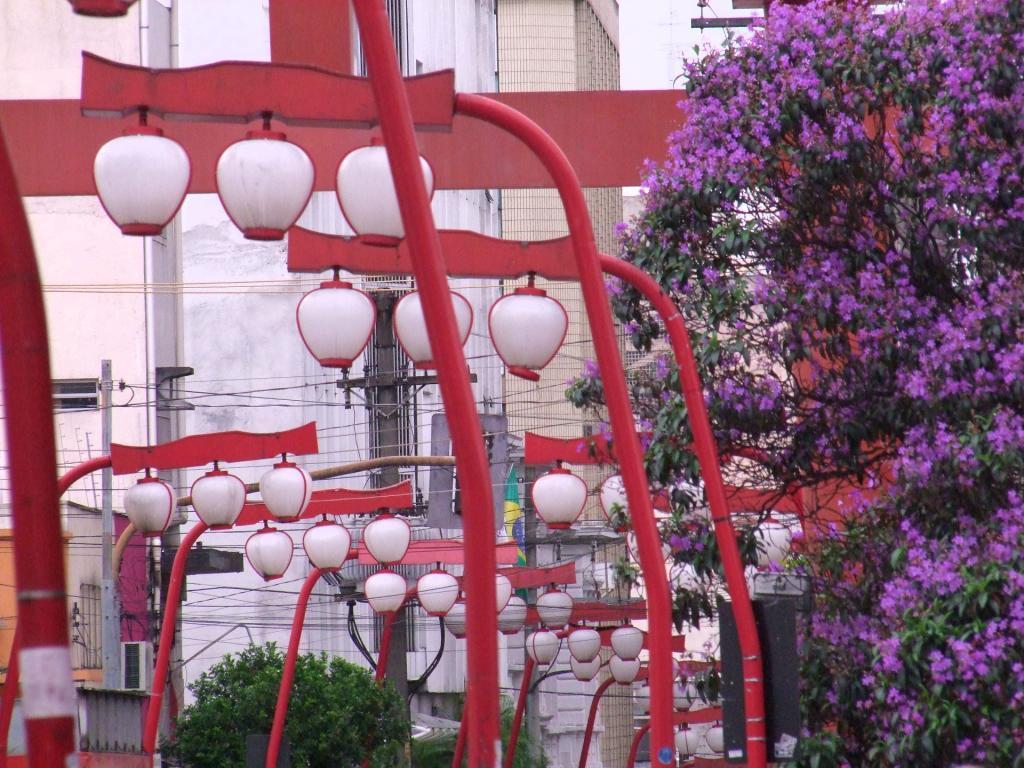Could you give a brief overview of what you see in this image? In this image in front we can see light poles. At the back side there are buildings, trees, current poles and at the top there is the sky. 